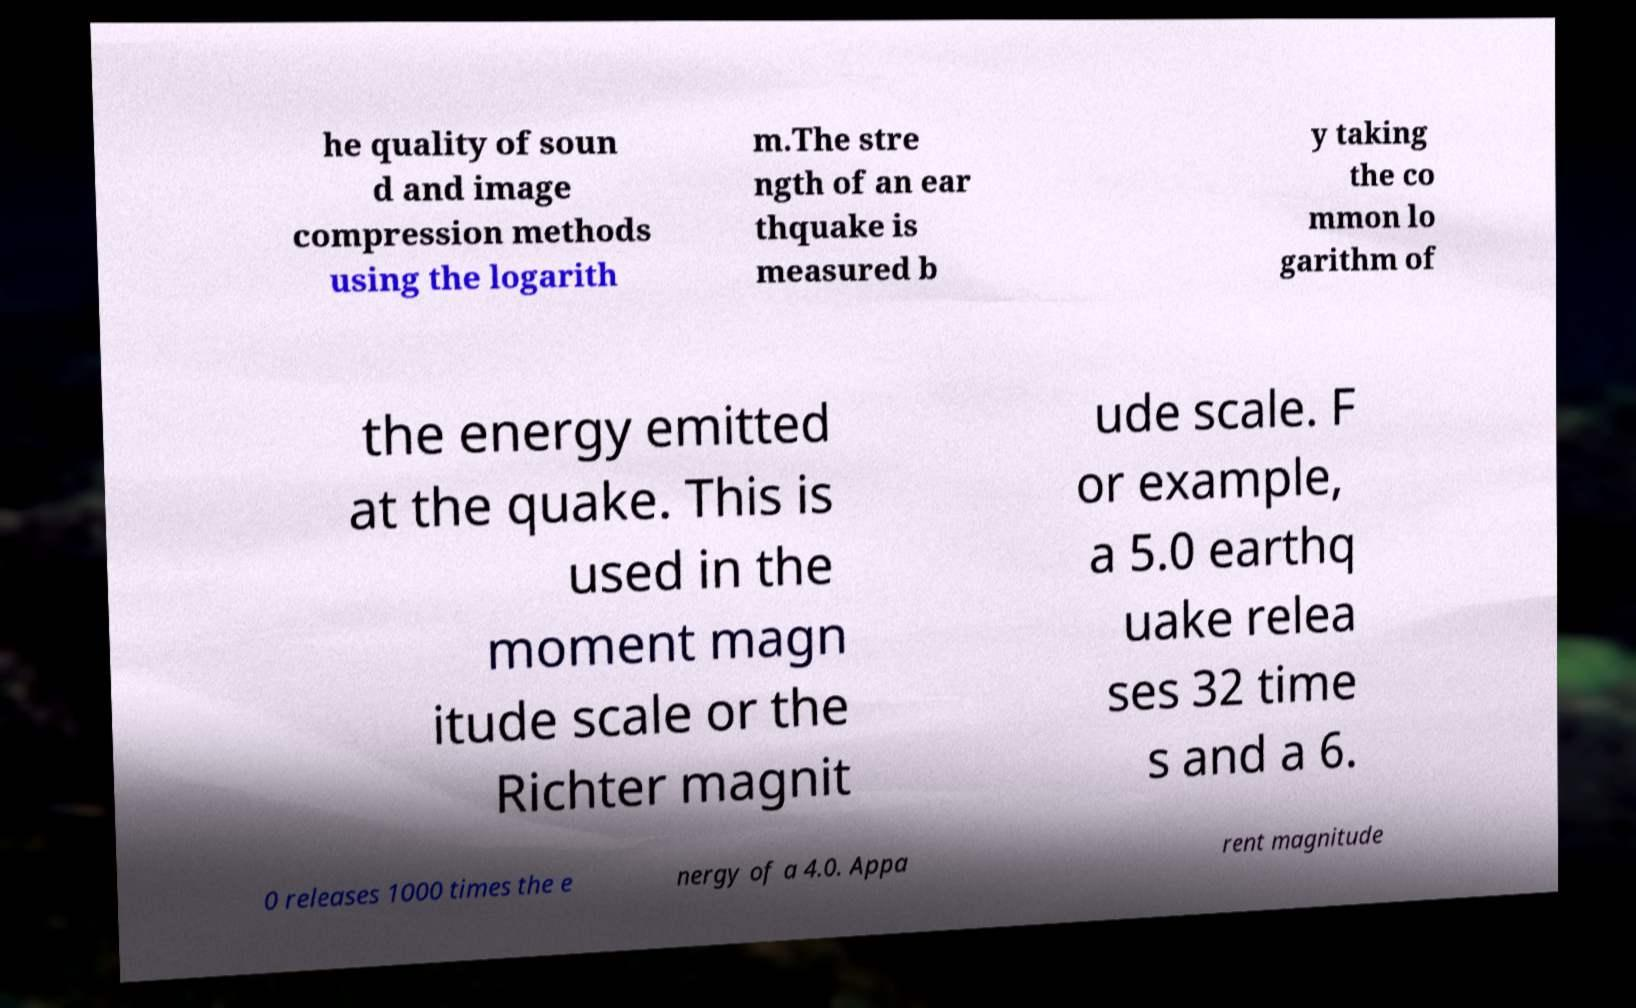What messages or text are displayed in this image? I need them in a readable, typed format. he quality of soun d and image compression methods using the logarith m.The stre ngth of an ear thquake is measured b y taking the co mmon lo garithm of the energy emitted at the quake. This is used in the moment magn itude scale or the Richter magnit ude scale. F or example, a 5.0 earthq uake relea ses 32 time s and a 6. 0 releases 1000 times the e nergy of a 4.0. Appa rent magnitude 